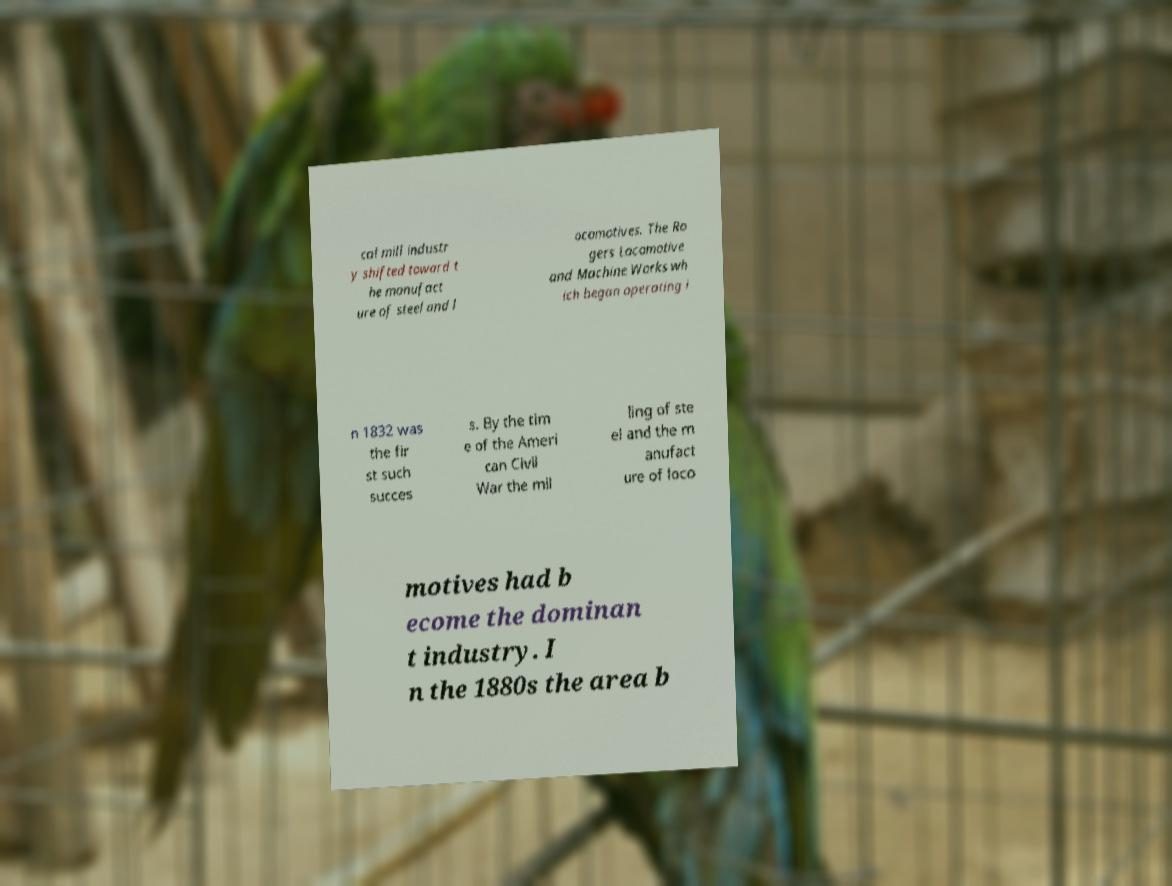Please read and relay the text visible in this image. What does it say? cal mill industr y shifted toward t he manufact ure of steel and l ocomotives. The Ro gers Locomotive and Machine Works wh ich began operating i n 1832 was the fir st such succes s. By the tim e of the Ameri can Civil War the mil ling of ste el and the m anufact ure of loco motives had b ecome the dominan t industry. I n the 1880s the area b 